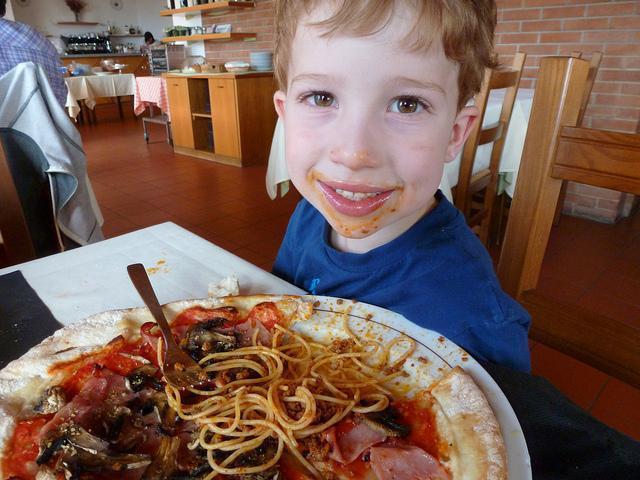How many dining tables can be seen?
Give a very brief answer. 2. How many chairs are there?
Give a very brief answer. 3. How many people are in the picture?
Give a very brief answer. 2. 